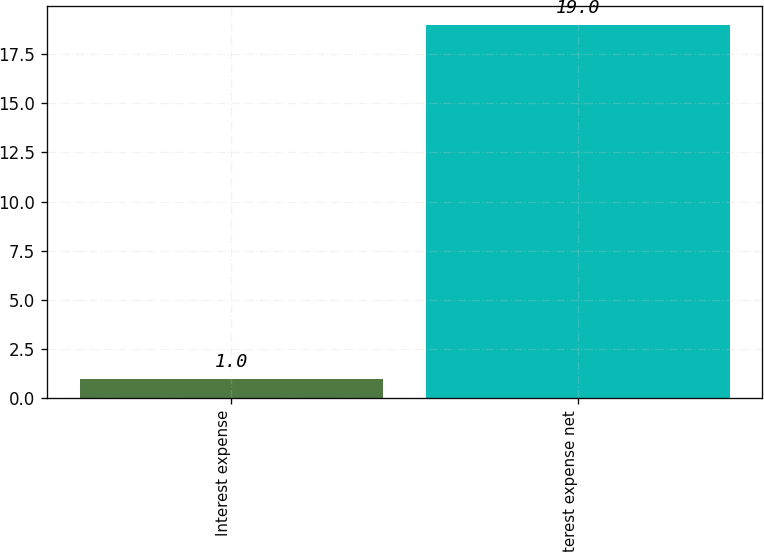Convert chart. <chart><loc_0><loc_0><loc_500><loc_500><bar_chart><fcel>Interest expense<fcel>Interest expense net<nl><fcel>1<fcel>19<nl></chart> 